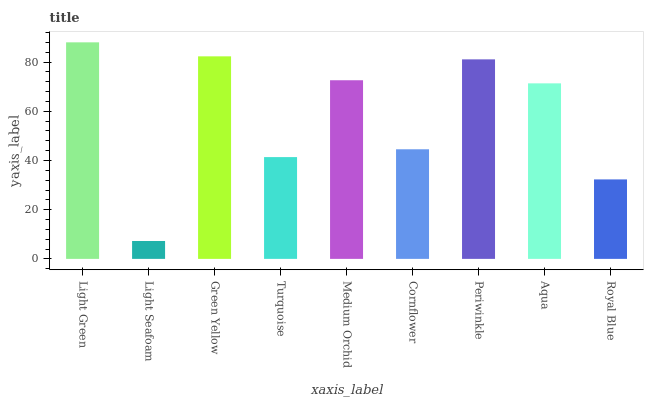Is Light Seafoam the minimum?
Answer yes or no. Yes. Is Light Green the maximum?
Answer yes or no. Yes. Is Green Yellow the minimum?
Answer yes or no. No. Is Green Yellow the maximum?
Answer yes or no. No. Is Green Yellow greater than Light Seafoam?
Answer yes or no. Yes. Is Light Seafoam less than Green Yellow?
Answer yes or no. Yes. Is Light Seafoam greater than Green Yellow?
Answer yes or no. No. Is Green Yellow less than Light Seafoam?
Answer yes or no. No. Is Aqua the high median?
Answer yes or no. Yes. Is Aqua the low median?
Answer yes or no. Yes. Is Periwinkle the high median?
Answer yes or no. No. Is Light Seafoam the low median?
Answer yes or no. No. 